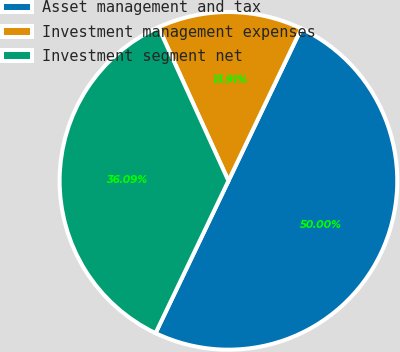<chart> <loc_0><loc_0><loc_500><loc_500><pie_chart><fcel>Asset management and tax<fcel>Investment management expenses<fcel>Investment segment net<nl><fcel>50.0%<fcel>13.91%<fcel>36.09%<nl></chart> 